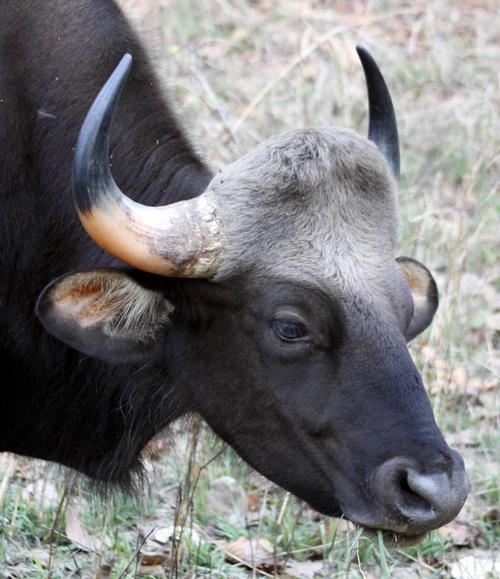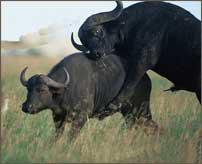The first image is the image on the left, the second image is the image on the right. For the images shown, is this caption "In at least one image there is Least one large horned gray adult bull in the water." true? Answer yes or no. No. The first image is the image on the left, the second image is the image on the right. Given the left and right images, does the statement "There are more than three animals total." hold true? Answer yes or no. No. 